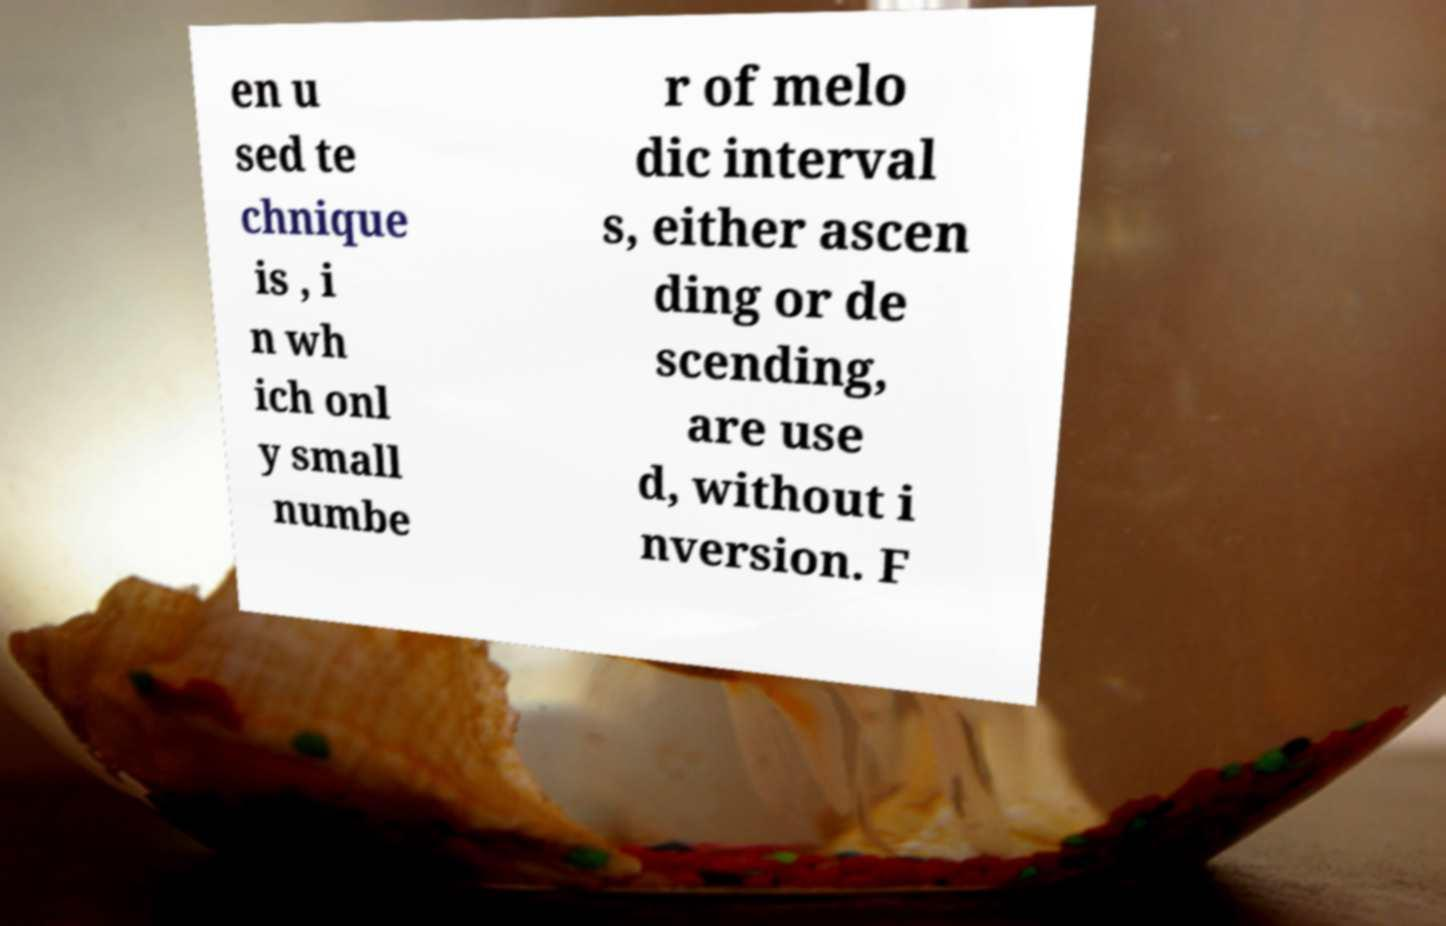Please identify and transcribe the text found in this image. en u sed te chnique is , i n wh ich onl y small numbe r of melo dic interval s, either ascen ding or de scending, are use d, without i nversion. F 